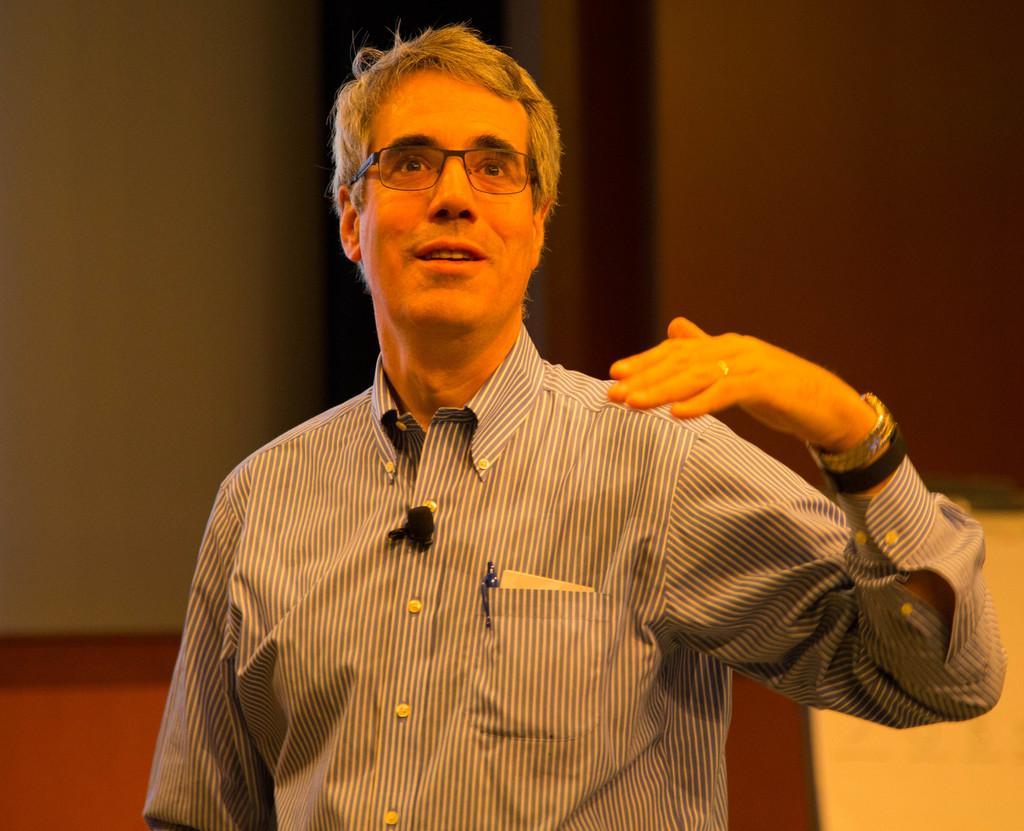Describe this image in one or two sentences. In this image, we can see a person wearing clothes and spectacles. In the background, image is blurred. 